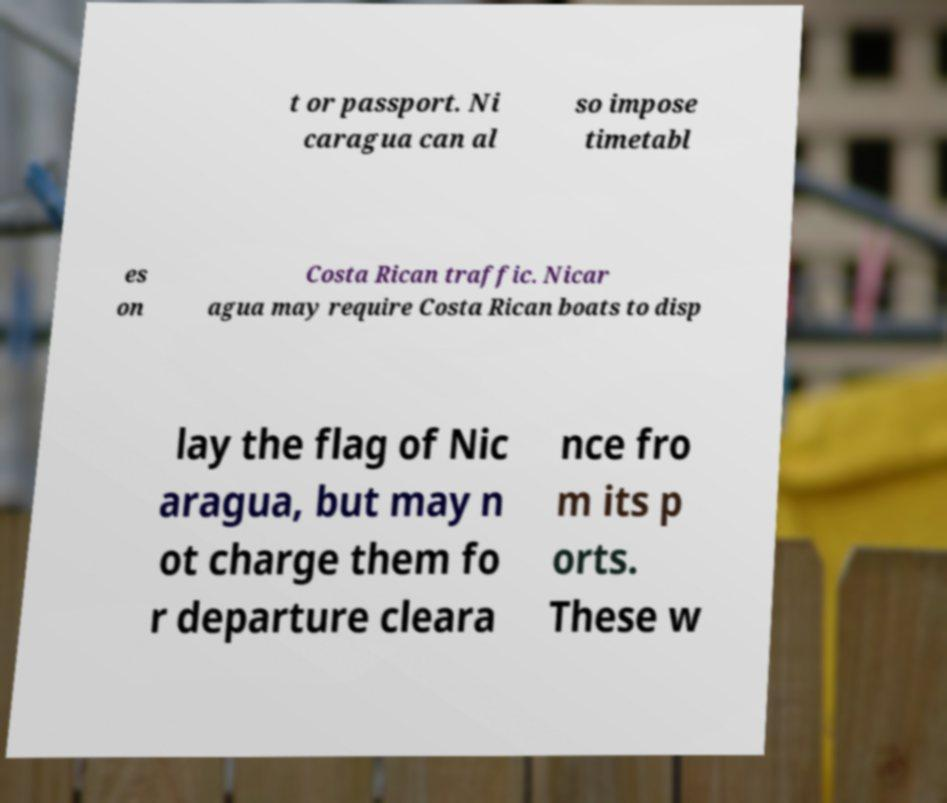Please identify and transcribe the text found in this image. t or passport. Ni caragua can al so impose timetabl es on Costa Rican traffic. Nicar agua may require Costa Rican boats to disp lay the flag of Nic aragua, but may n ot charge them fo r departure cleara nce fro m its p orts. These w 